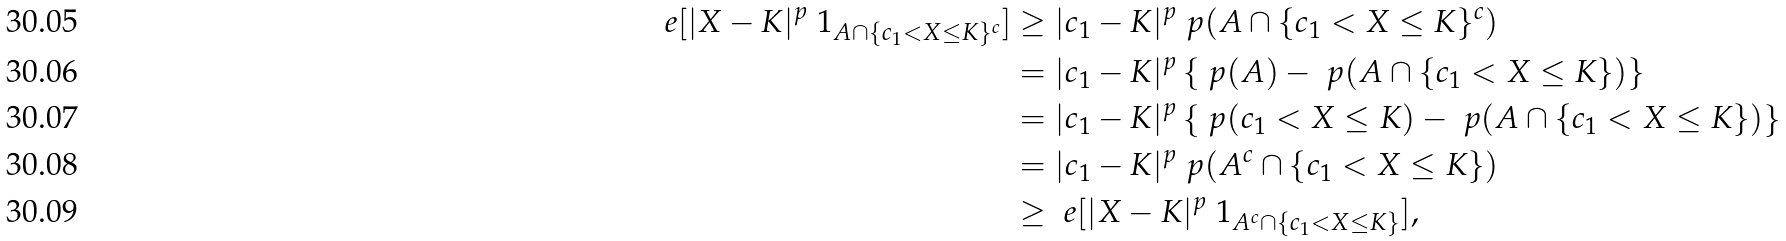Convert formula to latex. <formula><loc_0><loc_0><loc_500><loc_500>\ e [ | X - K | ^ { p } \ 1 _ { A \cap \{ c _ { 1 } < X \leq K \} ^ { c } } ] & \geq | c _ { 1 } - K | ^ { p } \ p ( A \cap \{ c _ { 1 } < X \leq K \} ^ { c } ) \\ & = | c _ { 1 } - K | ^ { p } \left \{ \ p ( A ) - \ p ( A \cap \{ c _ { 1 } < X \leq K \} ) \right \} \\ & = | c _ { 1 } - K | ^ { p } \left \{ \ p ( c _ { 1 } < X \leq K ) - \ p ( A \cap \{ c _ { 1 } < X \leq K \} ) \right \} \\ & = | c _ { 1 } - K | ^ { p } \ p ( A ^ { c } \cap \{ c _ { 1 } < X \leq K \} ) \\ & \geq \ e [ | X - K | ^ { p } \ 1 _ { A ^ { c } \cap \{ c _ { 1 } < X \leq K \} } ] ,</formula> 